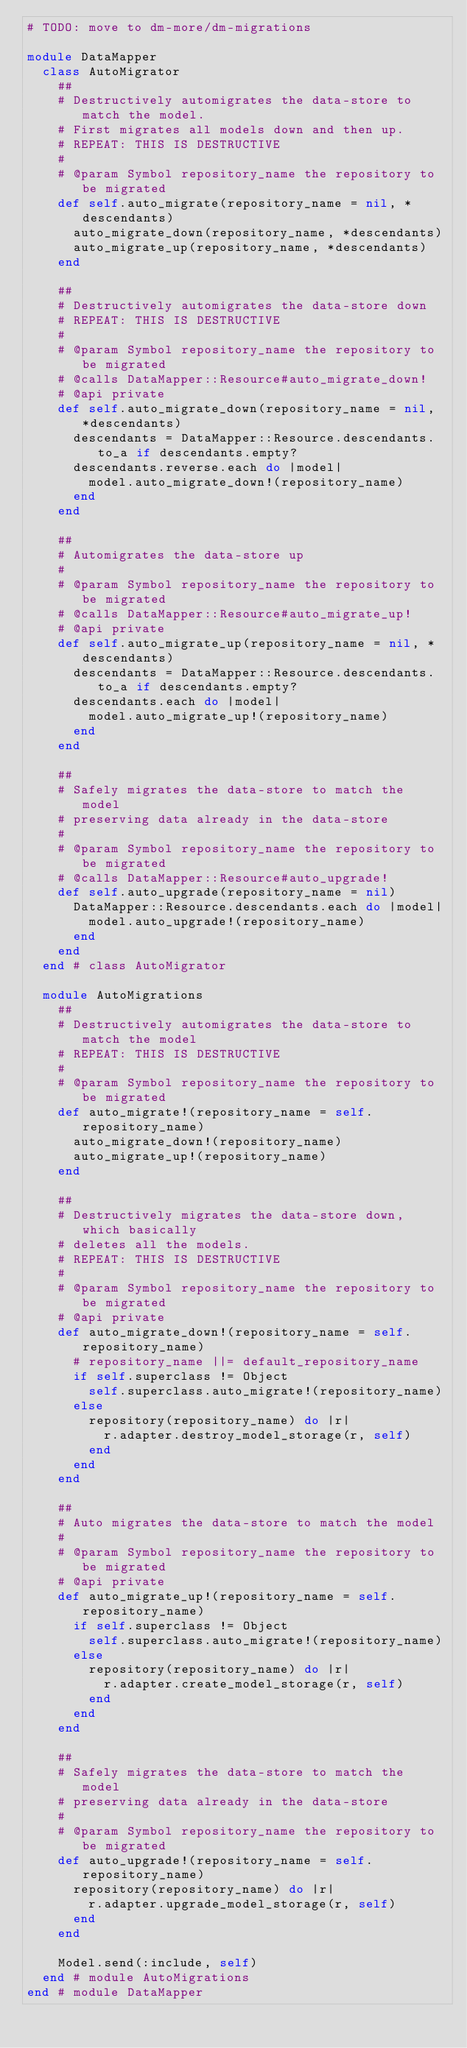<code> <loc_0><loc_0><loc_500><loc_500><_Ruby_># TODO: move to dm-more/dm-migrations

module DataMapper
  class AutoMigrator
    ##
    # Destructively automigrates the data-store to match the model.
    # First migrates all models down and then up.
    # REPEAT: THIS IS DESTRUCTIVE
    #
    # @param Symbol repository_name the repository to be migrated
    def self.auto_migrate(repository_name = nil, *descendants)
      auto_migrate_down(repository_name, *descendants)
      auto_migrate_up(repository_name, *descendants)
    end

    ##
    # Destructively automigrates the data-store down
    # REPEAT: THIS IS DESTRUCTIVE
    #
    # @param Symbol repository_name the repository to be migrated
    # @calls DataMapper::Resource#auto_migrate_down!
    # @api private
    def self.auto_migrate_down(repository_name = nil, *descendants)
      descendants = DataMapper::Resource.descendants.to_a if descendants.empty?
      descendants.reverse.each do |model|
        model.auto_migrate_down!(repository_name)
      end
    end

    ##
    # Automigrates the data-store up
    #
    # @param Symbol repository_name the repository to be migrated
    # @calls DataMapper::Resource#auto_migrate_up!
    # @api private
    def self.auto_migrate_up(repository_name = nil, *descendants)
      descendants = DataMapper::Resource.descendants.to_a if descendants.empty?
      descendants.each do |model|
        model.auto_migrate_up!(repository_name)
      end
    end

    ##
    # Safely migrates the data-store to match the model
    # preserving data already in the data-store
    #
    # @param Symbol repository_name the repository to be migrated
    # @calls DataMapper::Resource#auto_upgrade!
    def self.auto_upgrade(repository_name = nil)
      DataMapper::Resource.descendants.each do |model|
        model.auto_upgrade!(repository_name)
      end
    end
  end # class AutoMigrator

  module AutoMigrations
    ##
    # Destructively automigrates the data-store to match the model
    # REPEAT: THIS IS DESTRUCTIVE
    #
    # @param Symbol repository_name the repository to be migrated
    def auto_migrate!(repository_name = self.repository_name)
      auto_migrate_down!(repository_name)
      auto_migrate_up!(repository_name)
    end

    ##
    # Destructively migrates the data-store down, which basically
    # deletes all the models.
    # REPEAT: THIS IS DESTRUCTIVE
    #
    # @param Symbol repository_name the repository to be migrated
    # @api private
    def auto_migrate_down!(repository_name = self.repository_name)
      # repository_name ||= default_repository_name
      if self.superclass != Object
        self.superclass.auto_migrate!(repository_name)
      else
        repository(repository_name) do |r|
          r.adapter.destroy_model_storage(r, self)
        end
      end
    end

    ##
    # Auto migrates the data-store to match the model
    #
    # @param Symbol repository_name the repository to be migrated
    # @api private
    def auto_migrate_up!(repository_name = self.repository_name)
      if self.superclass != Object
        self.superclass.auto_migrate!(repository_name)
      else
        repository(repository_name) do |r|
          r.adapter.create_model_storage(r, self)
        end
      end
    end

    ##
    # Safely migrates the data-store to match the model
    # preserving data already in the data-store
    #
    # @param Symbol repository_name the repository to be migrated
    def auto_upgrade!(repository_name = self.repository_name)
      repository(repository_name) do |r|
        r.adapter.upgrade_model_storage(r, self)
      end
    end

    Model.send(:include, self)
  end # module AutoMigrations
end # module DataMapper
</code> 